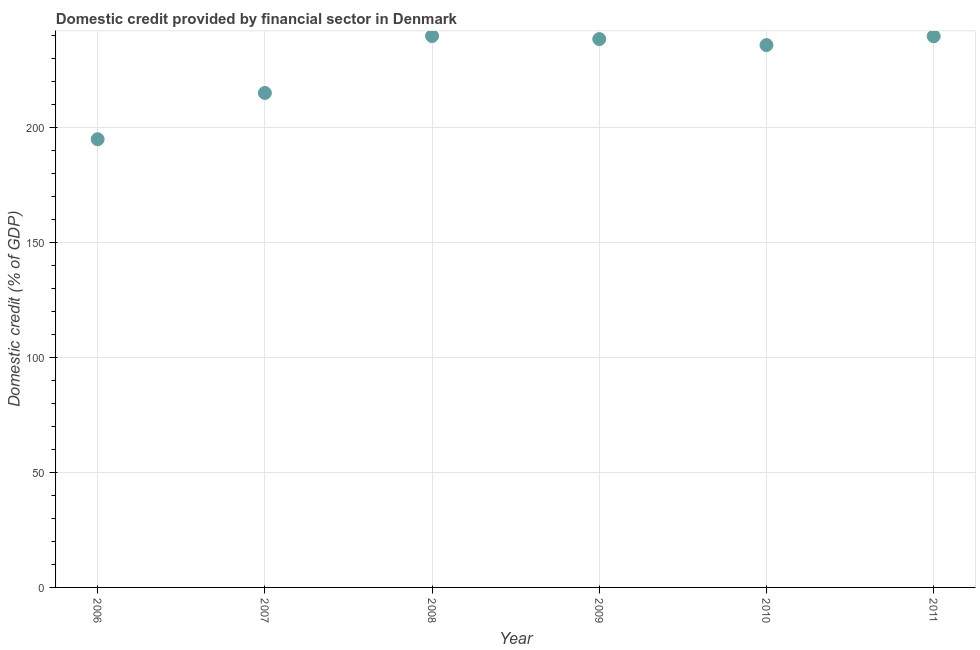What is the domestic credit provided by financial sector in 2008?
Your answer should be very brief. 239.64. Across all years, what is the maximum domestic credit provided by financial sector?
Give a very brief answer. 239.64. Across all years, what is the minimum domestic credit provided by financial sector?
Provide a short and direct response. 194.77. What is the sum of the domestic credit provided by financial sector?
Your response must be concise. 1362.82. What is the difference between the domestic credit provided by financial sector in 2009 and 2011?
Your answer should be compact. -1.22. What is the average domestic credit provided by financial sector per year?
Provide a succinct answer. 227.14. What is the median domestic credit provided by financial sector?
Your answer should be compact. 237. In how many years, is the domestic credit provided by financial sector greater than 170 %?
Your response must be concise. 6. Do a majority of the years between 2006 and 2011 (inclusive) have domestic credit provided by financial sector greater than 20 %?
Your answer should be compact. Yes. What is the ratio of the domestic credit provided by financial sector in 2007 to that in 2008?
Your response must be concise. 0.9. What is the difference between the highest and the second highest domestic credit provided by financial sector?
Your response must be concise. 0.12. Is the sum of the domestic credit provided by financial sector in 2007 and 2009 greater than the maximum domestic credit provided by financial sector across all years?
Your response must be concise. Yes. What is the difference between the highest and the lowest domestic credit provided by financial sector?
Offer a terse response. 44.87. Does the domestic credit provided by financial sector monotonically increase over the years?
Provide a short and direct response. No. How many years are there in the graph?
Make the answer very short. 6. Are the values on the major ticks of Y-axis written in scientific E-notation?
Offer a terse response. No. Does the graph contain any zero values?
Your answer should be very brief. No. Does the graph contain grids?
Ensure brevity in your answer.  Yes. What is the title of the graph?
Make the answer very short. Domestic credit provided by financial sector in Denmark. What is the label or title of the Y-axis?
Offer a very short reply. Domestic credit (% of GDP). What is the Domestic credit (% of GDP) in 2006?
Your answer should be very brief. 194.77. What is the Domestic credit (% of GDP) in 2007?
Ensure brevity in your answer.  214.89. What is the Domestic credit (% of GDP) in 2008?
Offer a terse response. 239.64. What is the Domestic credit (% of GDP) in 2009?
Keep it short and to the point. 238.3. What is the Domestic credit (% of GDP) in 2010?
Your answer should be compact. 235.69. What is the Domestic credit (% of GDP) in 2011?
Keep it short and to the point. 239.52. What is the difference between the Domestic credit (% of GDP) in 2006 and 2007?
Give a very brief answer. -20.12. What is the difference between the Domestic credit (% of GDP) in 2006 and 2008?
Give a very brief answer. -44.87. What is the difference between the Domestic credit (% of GDP) in 2006 and 2009?
Make the answer very short. -43.53. What is the difference between the Domestic credit (% of GDP) in 2006 and 2010?
Make the answer very short. -40.92. What is the difference between the Domestic credit (% of GDP) in 2006 and 2011?
Your response must be concise. -44.75. What is the difference between the Domestic credit (% of GDP) in 2007 and 2008?
Provide a succinct answer. -24.75. What is the difference between the Domestic credit (% of GDP) in 2007 and 2009?
Keep it short and to the point. -23.41. What is the difference between the Domestic credit (% of GDP) in 2007 and 2010?
Ensure brevity in your answer.  -20.8. What is the difference between the Domestic credit (% of GDP) in 2007 and 2011?
Make the answer very short. -24.63. What is the difference between the Domestic credit (% of GDP) in 2008 and 2009?
Give a very brief answer. 1.34. What is the difference between the Domestic credit (% of GDP) in 2008 and 2010?
Provide a short and direct response. 3.95. What is the difference between the Domestic credit (% of GDP) in 2008 and 2011?
Your answer should be very brief. 0.12. What is the difference between the Domestic credit (% of GDP) in 2009 and 2010?
Your answer should be compact. 2.61. What is the difference between the Domestic credit (% of GDP) in 2009 and 2011?
Provide a short and direct response. -1.22. What is the difference between the Domestic credit (% of GDP) in 2010 and 2011?
Keep it short and to the point. -3.83. What is the ratio of the Domestic credit (% of GDP) in 2006 to that in 2007?
Offer a very short reply. 0.91. What is the ratio of the Domestic credit (% of GDP) in 2006 to that in 2008?
Keep it short and to the point. 0.81. What is the ratio of the Domestic credit (% of GDP) in 2006 to that in 2009?
Your answer should be compact. 0.82. What is the ratio of the Domestic credit (% of GDP) in 2006 to that in 2010?
Your answer should be compact. 0.83. What is the ratio of the Domestic credit (% of GDP) in 2006 to that in 2011?
Keep it short and to the point. 0.81. What is the ratio of the Domestic credit (% of GDP) in 2007 to that in 2008?
Make the answer very short. 0.9. What is the ratio of the Domestic credit (% of GDP) in 2007 to that in 2009?
Keep it short and to the point. 0.9. What is the ratio of the Domestic credit (% of GDP) in 2007 to that in 2010?
Ensure brevity in your answer.  0.91. What is the ratio of the Domestic credit (% of GDP) in 2007 to that in 2011?
Offer a terse response. 0.9. What is the ratio of the Domestic credit (% of GDP) in 2009 to that in 2010?
Keep it short and to the point. 1.01. What is the ratio of the Domestic credit (% of GDP) in 2009 to that in 2011?
Provide a succinct answer. 0.99. 